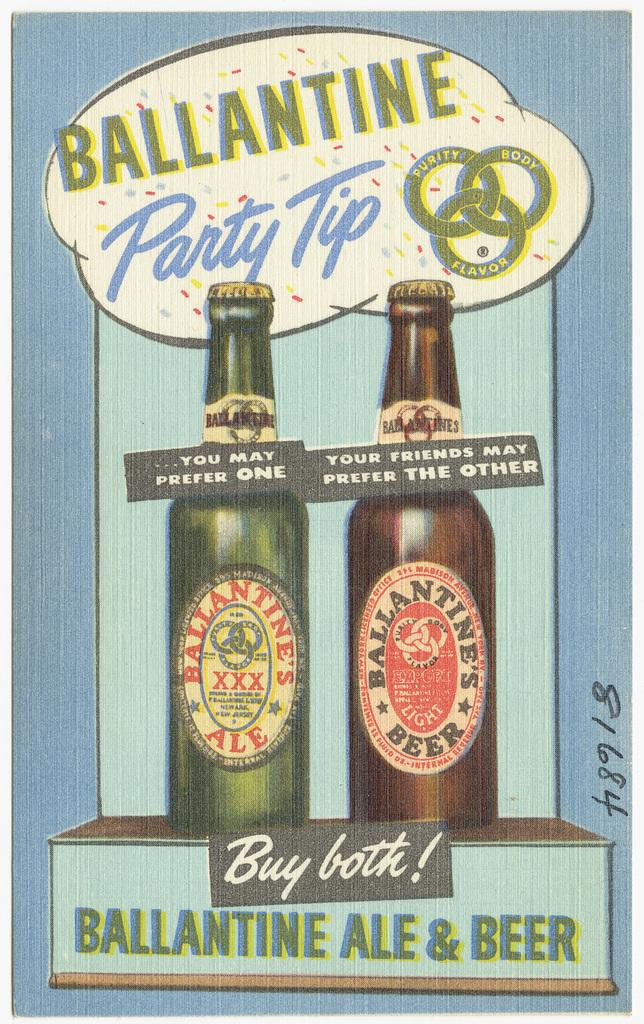What is featured in the image? There is a poster in the image. What type of images are on the poster? The poster contains images of bottles. Is there any text on the poster? Yes, there is text on the poster. What type of polish is being advertised on the poster? There is no polish being advertised on the poster; it contains images of bottles and text. What season is depicted on the poster? The poster does not depict a specific season; it features images of bottles and text. 